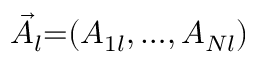Convert formula to latex. <formula><loc_0><loc_0><loc_500><loc_500>\vec { A } _ { l } { = } ( A _ { 1 l } , { \dots } , A _ { N l } )</formula> 